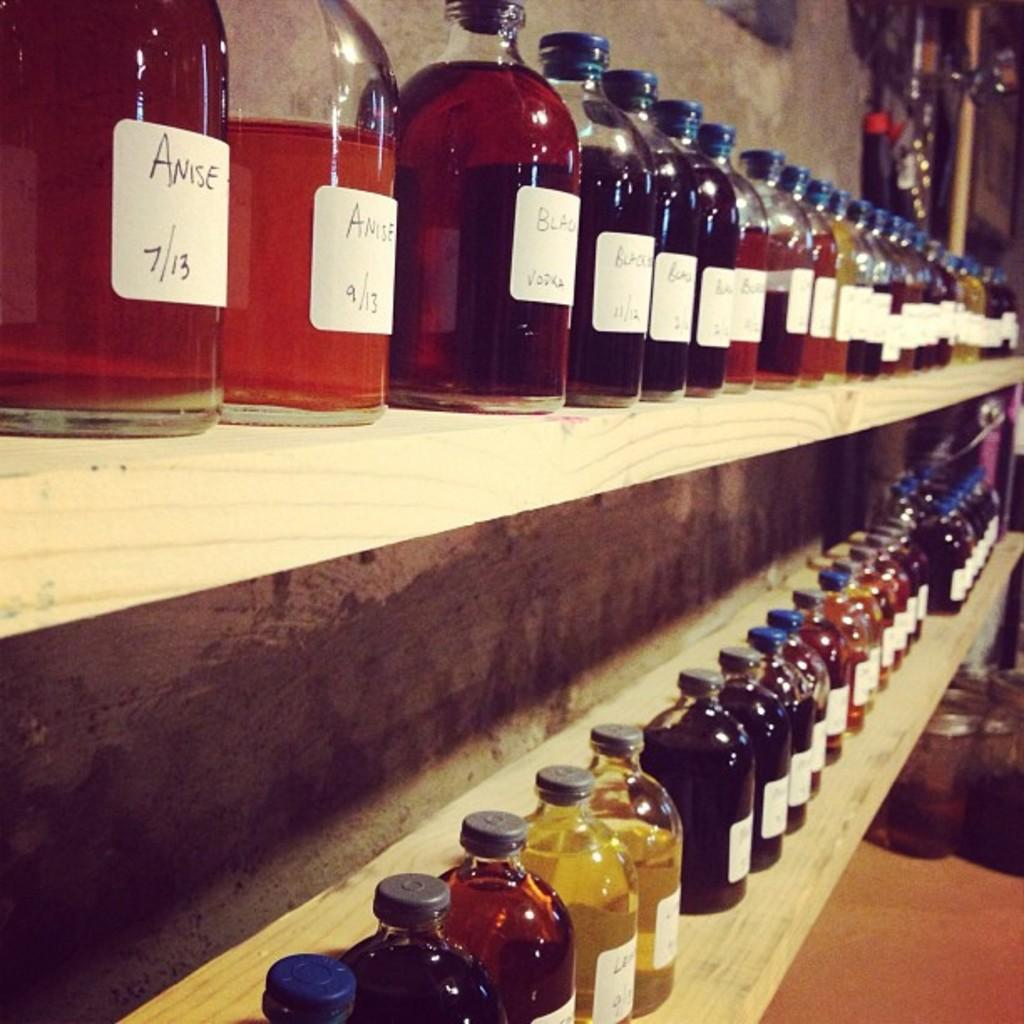<image>
Create a compact narrative representing the image presented. Seems like an alchemists shelves with bottles of Anise at the upper left. 